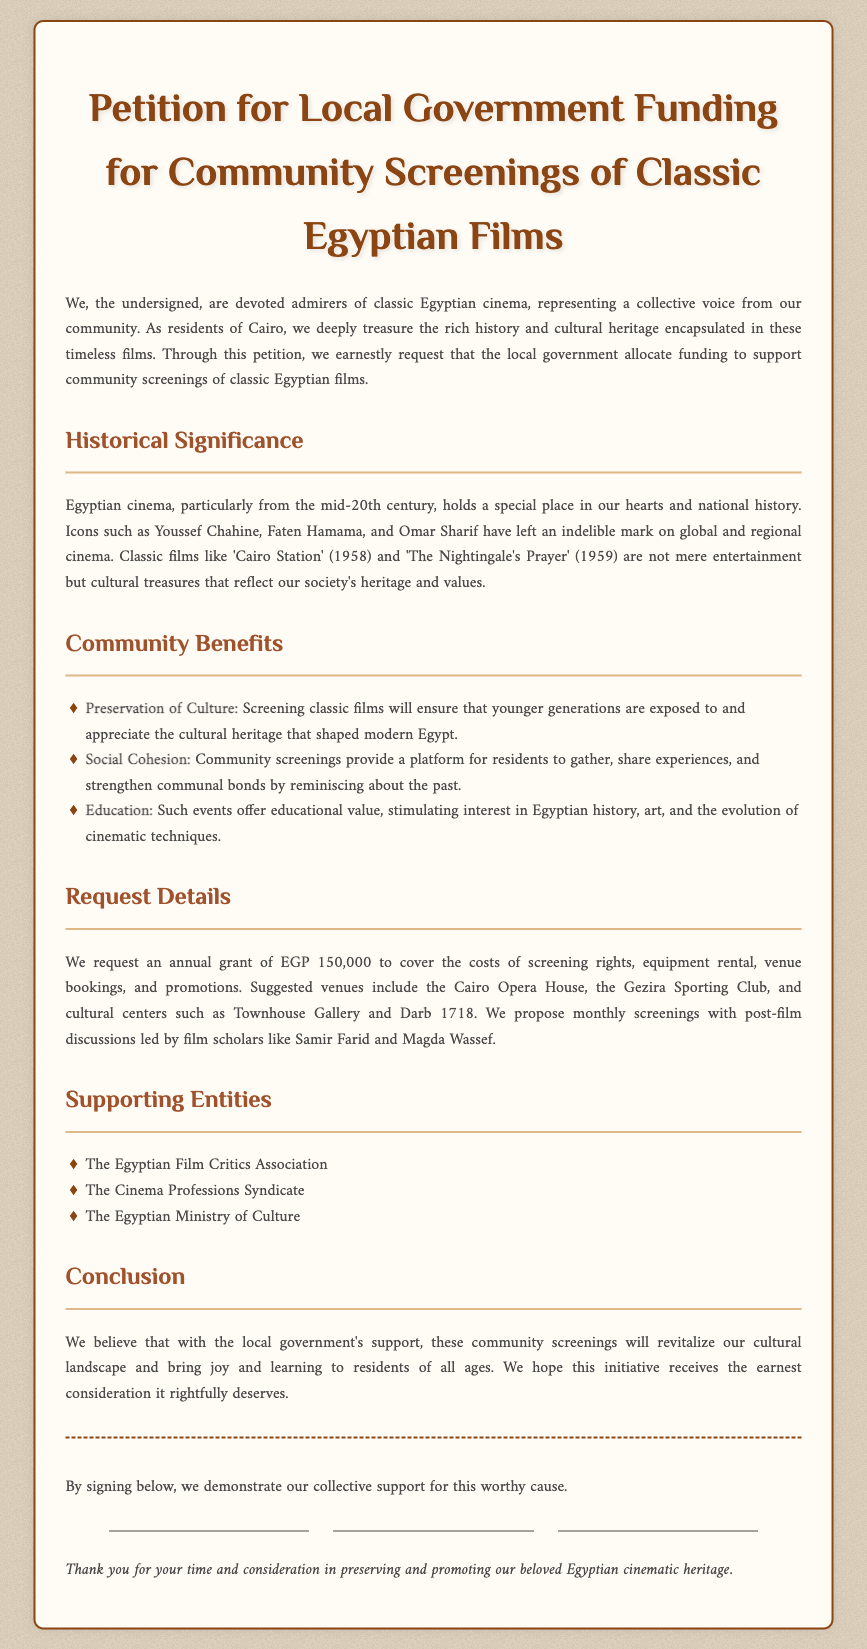What is the title of the petition? The title of the petition is stated at the beginning of the document as "Petition for Local Government Funding for Community Screenings of Classic Egyptian Films."
Answer: Petition for Local Government Funding for Community Screenings of Classic Egyptian Films How much funding is requested annually? The document specifies that an annual grant of EGP 150,000 is requested to cover various costs.
Answer: EGP 150,000 Which films are mentioned as cultural treasures? The document cites "Cairo Station" and "The Nightingale's Prayer" as classic films that reflect the society's heritage and values.
Answer: Cairo Station, The Nightingale's Prayer What are suggested venues for screenings? Suggested venues listed in the petition include the Cairo Opera House, Gezira Sporting Club, and cultural centers like Townhouse Gallery and Darb 1718.
Answer: Cairo Opera House, Gezira Sporting Club, Townhouse Gallery, Darb 1718 Who are some supporting entities for the petition? The document names supporting entities like the Egyptian Film Critics Association, the Cinema Professions Syndicate, and the Egyptian Ministry of Culture.
Answer: Egyptian Film Critics Association, Cinema Professions Syndicate, Egyptian Ministry of Culture What is the primary benefit of community screenings mentioned? The document highlights "Preservation of Culture" as a key benefit of screening classic films in the community.
Answer: Preservation of Culture What is the collective goal of the petition? The goal expressed in the document is to revitalize the cultural landscape and provide joy and learning to residents of all ages.
Answer: Revitalize cultural landscape What type of discussions are proposed after screenings? The petition proposes post-film discussions led by film scholars after the screenings.
Answer: Post-film discussions led by film scholars 